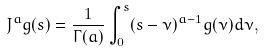<formula> <loc_0><loc_0><loc_500><loc_500>J ^ { a } g ( s ) = \frac { 1 } { \Gamma ( a ) } \int _ { 0 } ^ { s } ( s - \nu ) ^ { a - 1 } g ( \nu ) d \nu ,</formula> 